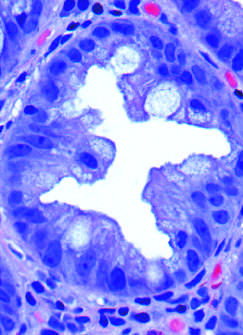how are the glands cut?
Answer the question using a single word or phrase. In cross-section 